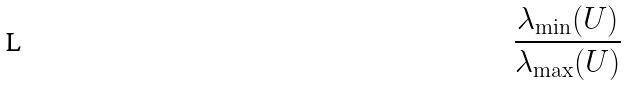<formula> <loc_0><loc_0><loc_500><loc_500>\frac { \lambda _ { \min } ( U ) } { \lambda _ { \max } ( U ) }</formula> 